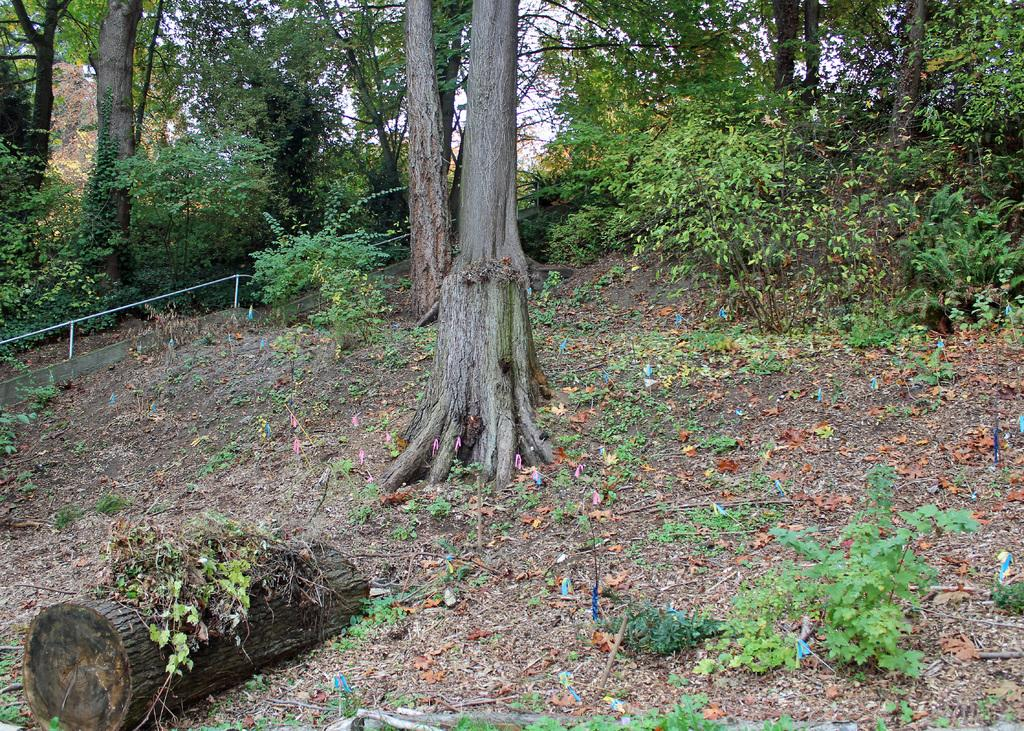What type of natural vegetation is present in the image? There are trees and plants in the image. What material are the metal rods made of in the image? The metal rods in the image are made of metal. What type of material is the wooden bark made of in the image? The wooden bark in the image is made of wood. What size are the plants in the image? The size of the plants cannot be determined from the image alone, as the image does not provide a reference for scale. How are the plants sorted in the image? The plants are not sorted in any particular order in the image. Can you stretch the wooden bark in the image? The wooden bark in the image is a static object and cannot be stretched. 